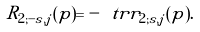Convert formula to latex. <formula><loc_0><loc_0><loc_500><loc_500>R _ { 2 ; - s , j } ( p ) = - \ t r r _ { 2 ; s , j } ( p ) .</formula> 